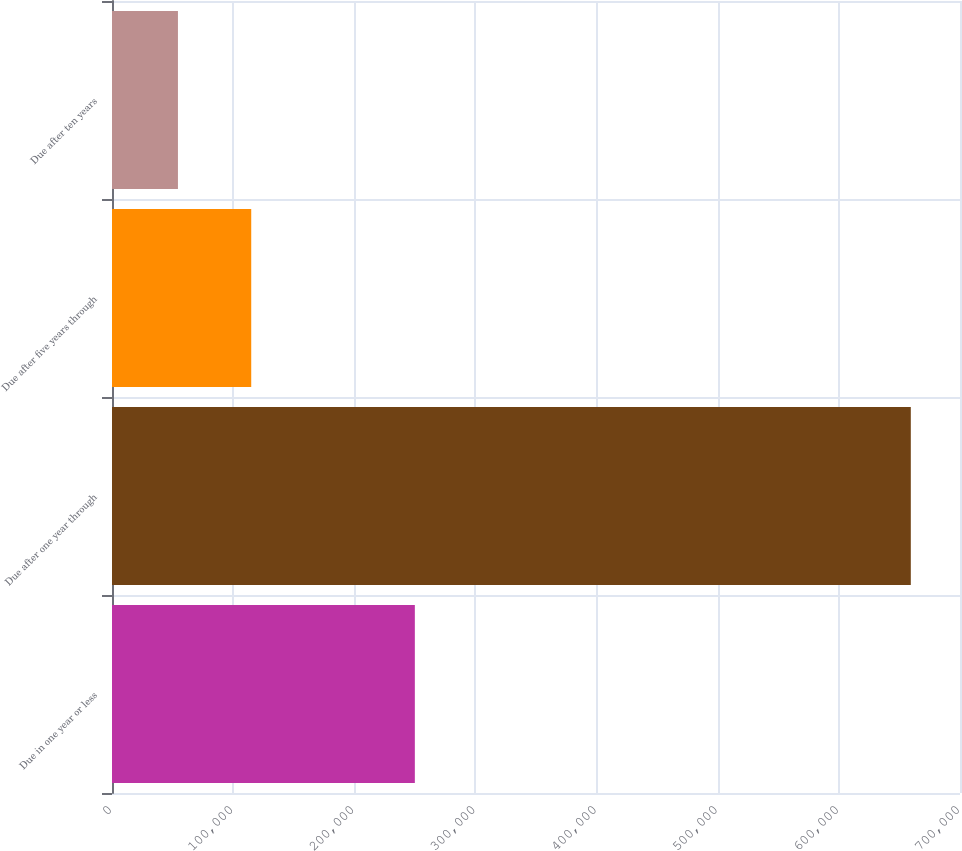Convert chart. <chart><loc_0><loc_0><loc_500><loc_500><bar_chart><fcel>Due in one year or less<fcel>Due after one year through<fcel>Due after five years through<fcel>Due after ten years<nl><fcel>249992<fcel>659393<fcel>114929<fcel>54433<nl></chart> 